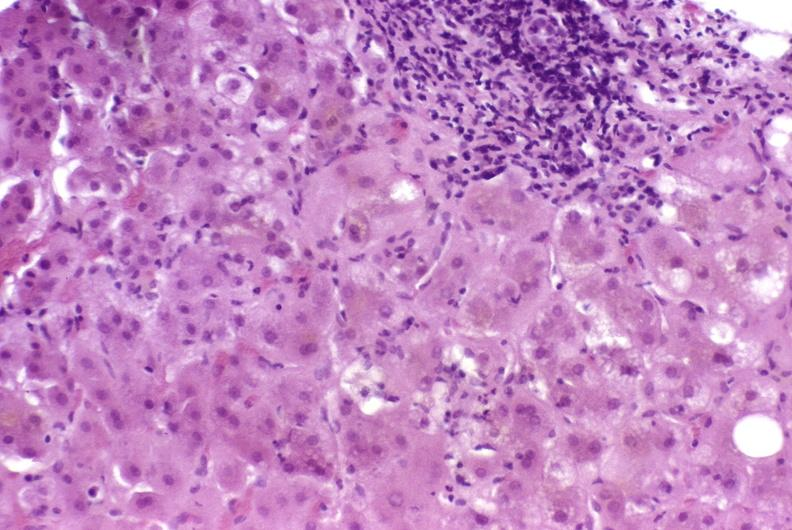does this image show autoimmune hepatitis?
Answer the question using a single word or phrase. Yes 